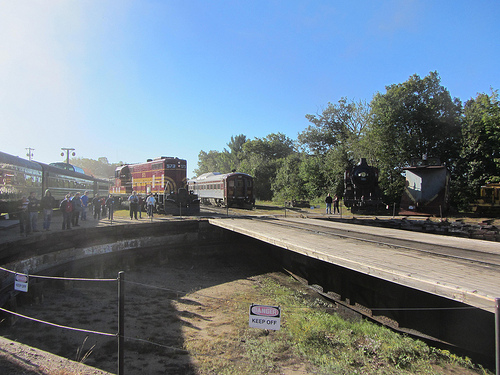Does the train that is to the right of the person look red? Yes, the train to the right of the person does appear to be red. 